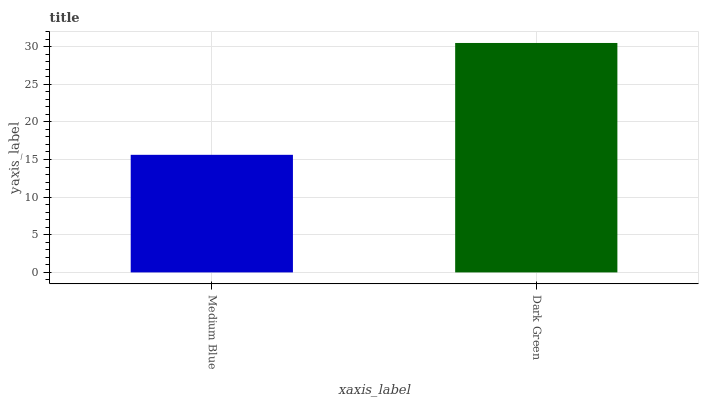Is Dark Green the minimum?
Answer yes or no. No. Is Dark Green greater than Medium Blue?
Answer yes or no. Yes. Is Medium Blue less than Dark Green?
Answer yes or no. Yes. Is Medium Blue greater than Dark Green?
Answer yes or no. No. Is Dark Green less than Medium Blue?
Answer yes or no. No. Is Dark Green the high median?
Answer yes or no. Yes. Is Medium Blue the low median?
Answer yes or no. Yes. Is Medium Blue the high median?
Answer yes or no. No. Is Dark Green the low median?
Answer yes or no. No. 